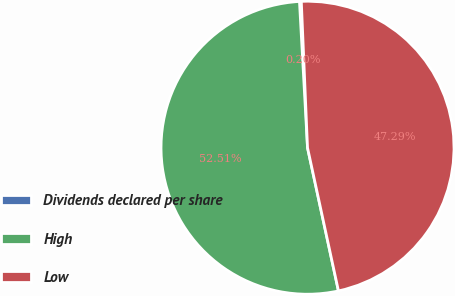Convert chart. <chart><loc_0><loc_0><loc_500><loc_500><pie_chart><fcel>Dividends declared per share<fcel>High<fcel>Low<nl><fcel>0.2%<fcel>52.51%<fcel>47.29%<nl></chart> 